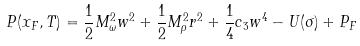<formula> <loc_0><loc_0><loc_500><loc_500>P ( x _ { F } , T ) = \frac { 1 } { 2 } M ^ { 2 } _ { \omega } w ^ { 2 } + \frac { 1 } { 2 } M ^ { 2 } _ { \rho } r ^ { 2 } + \frac { 1 } { 4 } c _ { 3 } w ^ { 4 } - U ( \sigma ) + P _ { F }</formula> 